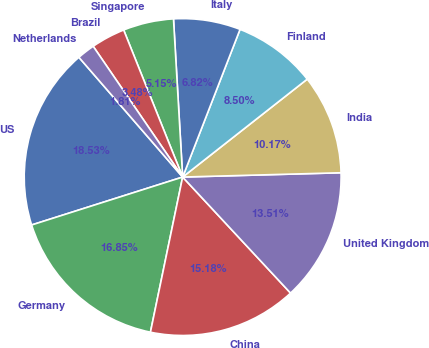Convert chart. <chart><loc_0><loc_0><loc_500><loc_500><pie_chart><fcel>US<fcel>Germany<fcel>China<fcel>United Kingdom<fcel>India<fcel>Finland<fcel>Italy<fcel>Singapore<fcel>Brazil<fcel>Netherlands<nl><fcel>18.53%<fcel>16.85%<fcel>15.18%<fcel>13.51%<fcel>10.17%<fcel>8.5%<fcel>6.82%<fcel>5.15%<fcel>3.48%<fcel>1.81%<nl></chart> 